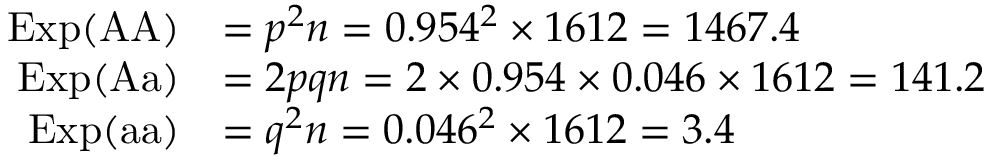<formula> <loc_0><loc_0><loc_500><loc_500>{ \begin{array} { r l } { E x p ( { A A } ) } & { = p ^ { 2 } n = 0 . 9 5 4 ^ { 2 } \times 1 6 1 2 = 1 4 6 7 . 4 } \\ { E x p ( { A a } ) } & { = 2 p q n = 2 \times 0 . 9 5 4 \times 0 . 0 4 6 \times 1 6 1 2 = 1 4 1 . 2 } \\ { E x p ( { a a } ) } & { = q ^ { 2 } n = 0 . 0 4 6 ^ { 2 } \times 1 6 1 2 = 3 . 4 } \end{array} }</formula> 